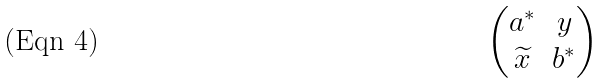Convert formula to latex. <formula><loc_0><loc_0><loc_500><loc_500>\begin{pmatrix} a ^ { * } & y \\ \widetilde { x } & b ^ { * } \end{pmatrix}</formula> 